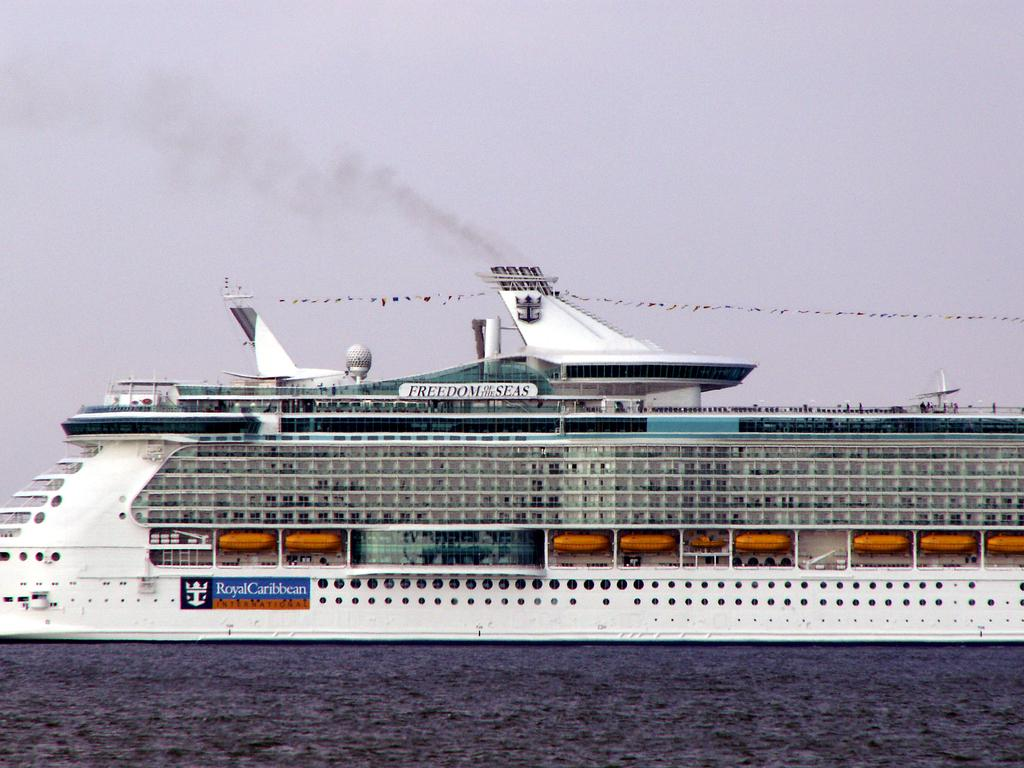What is the main subject of the image? There is a ship on a water body in the image. What can be seen coming from the ship? There is smoke visible in the image. How would you describe the sky in the image? The sky is clear in the image. How many snails can be seen on the ship in the image? There are no snails present on the ship in the image. What type of bait is being used by the ship in the image? There is no indication of fishing or bait usage in the image, as it features a ship on a water body with smoke. 